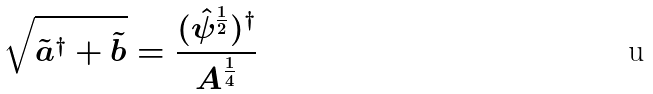Convert formula to latex. <formula><loc_0><loc_0><loc_500><loc_500>\sqrt { \tilde { a } ^ { \dag } + \tilde { b } } = \frac { ( \hat { \psi } ^ { \frac { 1 } { 2 } } ) ^ { \dag } } { A ^ { \frac { 1 } { 4 } } }</formula> 